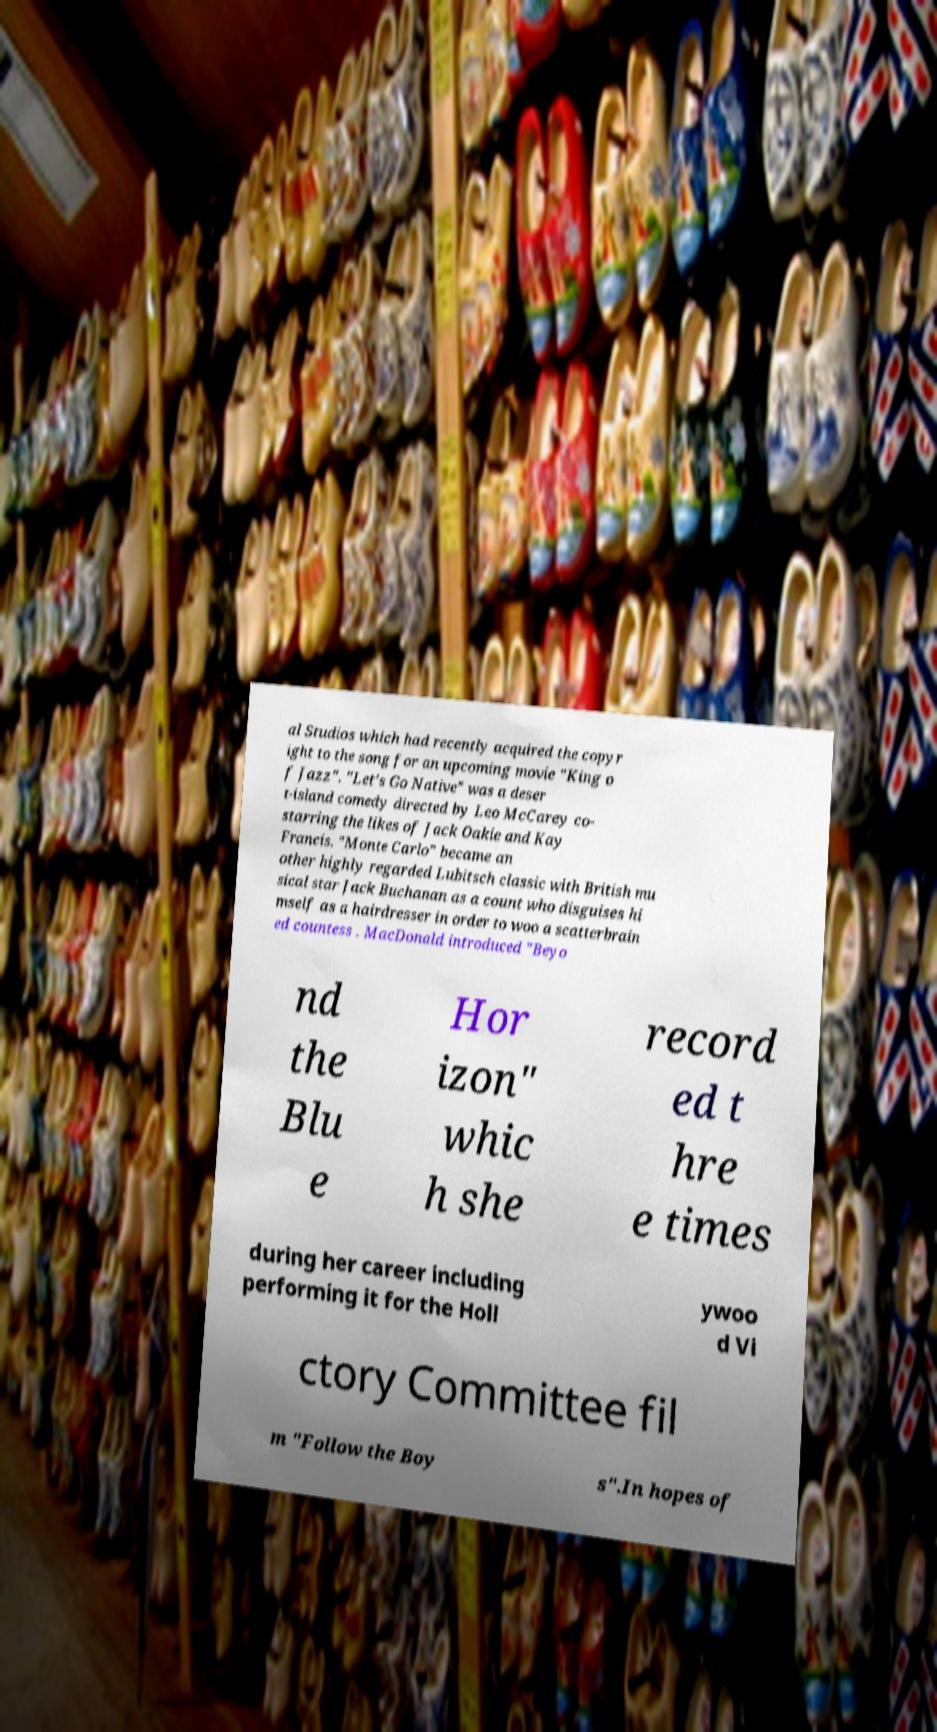What messages or text are displayed in this image? I need them in a readable, typed format. al Studios which had recently acquired the copyr ight to the song for an upcoming movie "King o f Jazz". "Let's Go Native" was a deser t-island comedy directed by Leo McCarey co- starring the likes of Jack Oakie and Kay Francis. "Monte Carlo" became an other highly regarded Lubitsch classic with British mu sical star Jack Buchanan as a count who disguises hi mself as a hairdresser in order to woo a scatterbrain ed countess . MacDonald introduced "Beyo nd the Blu e Hor izon" whic h she record ed t hre e times during her career including performing it for the Holl ywoo d Vi ctory Committee fil m "Follow the Boy s".In hopes of 